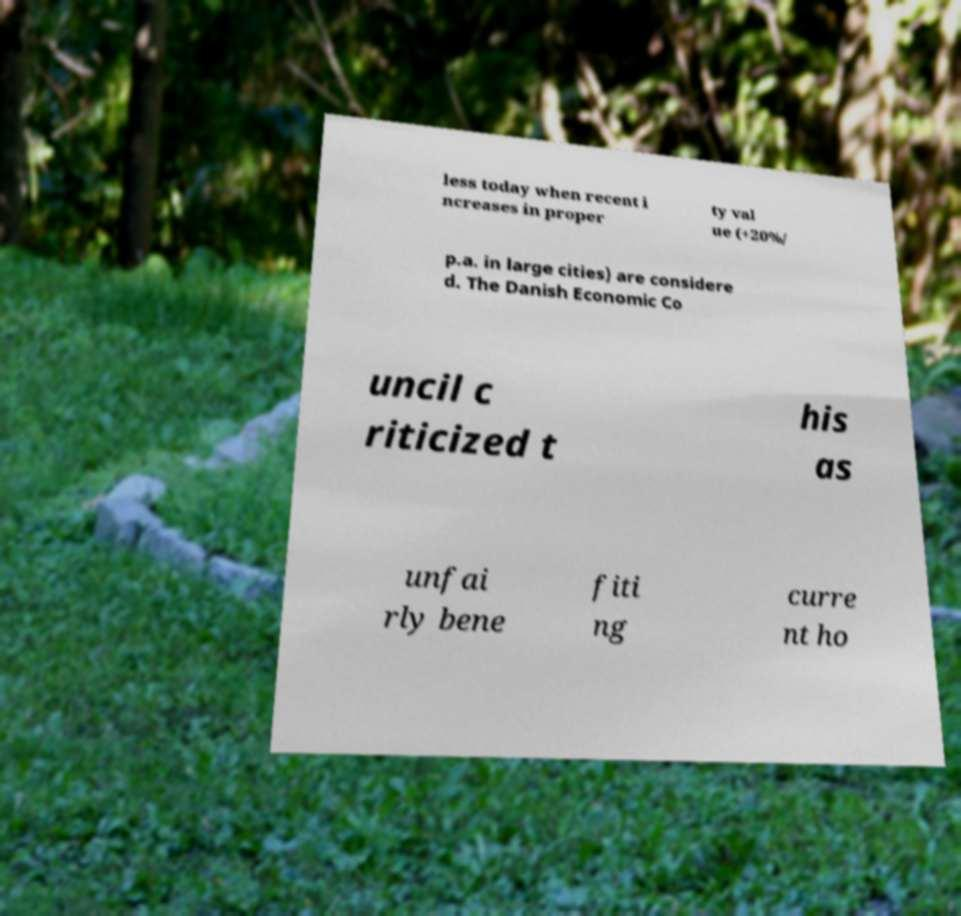Can you accurately transcribe the text from the provided image for me? less today when recent i ncreases in proper ty val ue (+20%/ p.a. in large cities) are considere d. The Danish Economic Co uncil c riticized t his as unfai rly bene fiti ng curre nt ho 